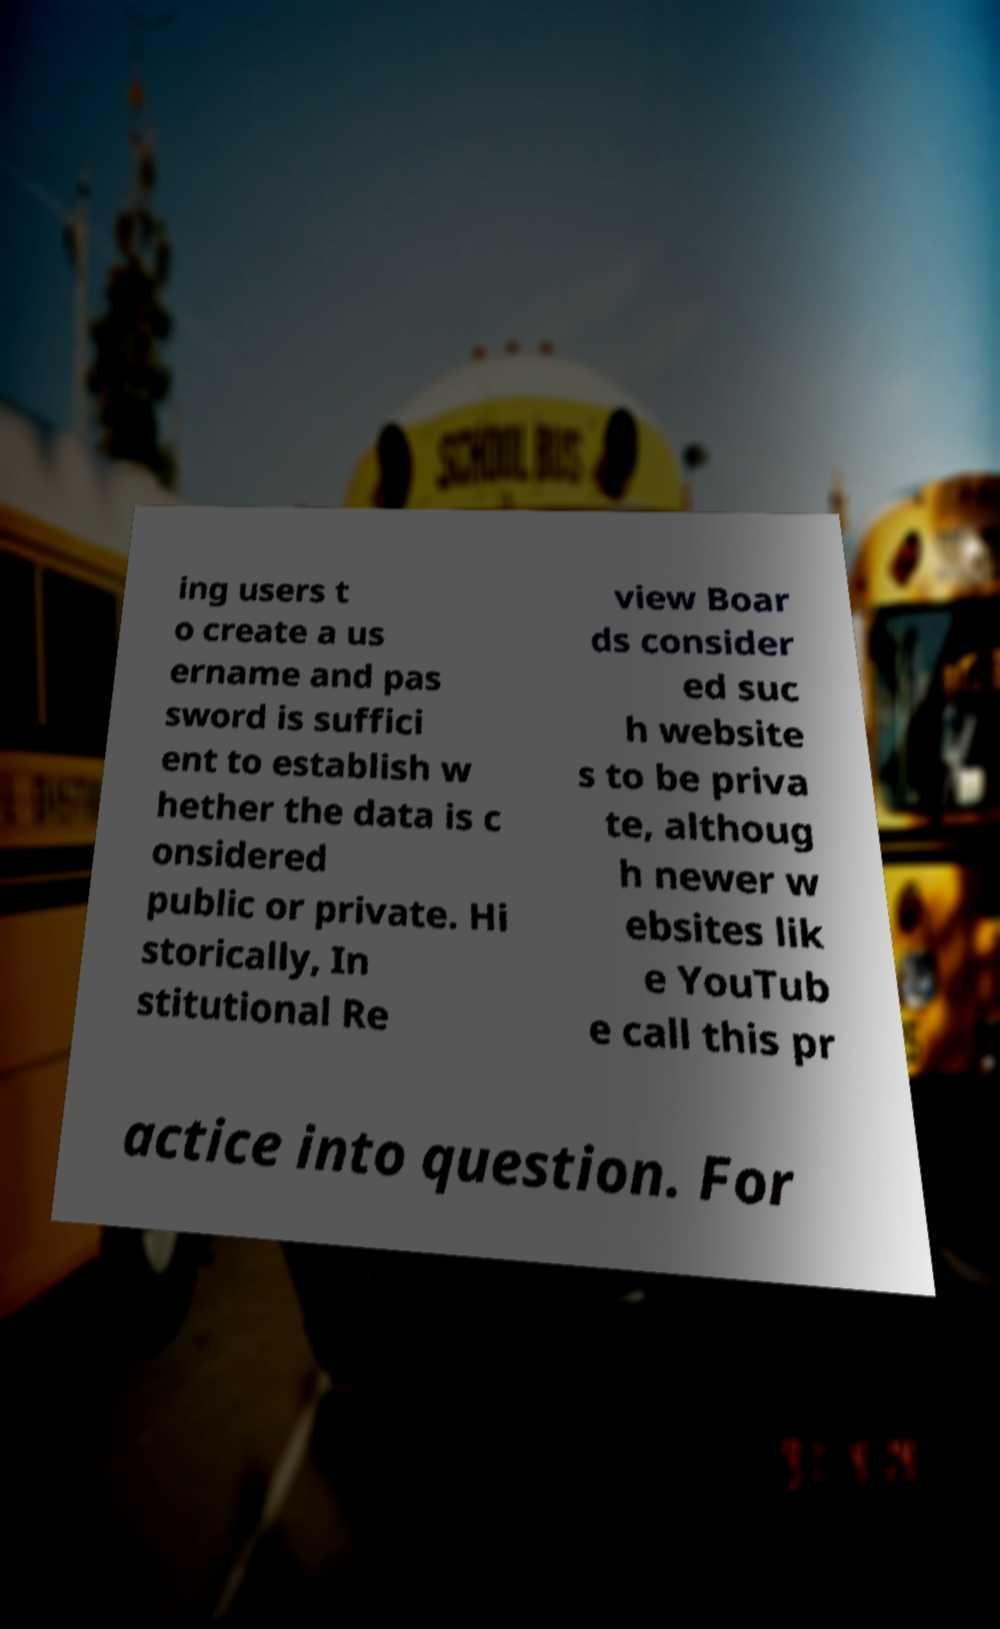What messages or text are displayed in this image? I need them in a readable, typed format. ing users t o create a us ername and pas sword is suffici ent to establish w hether the data is c onsidered public or private. Hi storically, In stitutional Re view Boar ds consider ed suc h website s to be priva te, althoug h newer w ebsites lik e YouTub e call this pr actice into question. For 